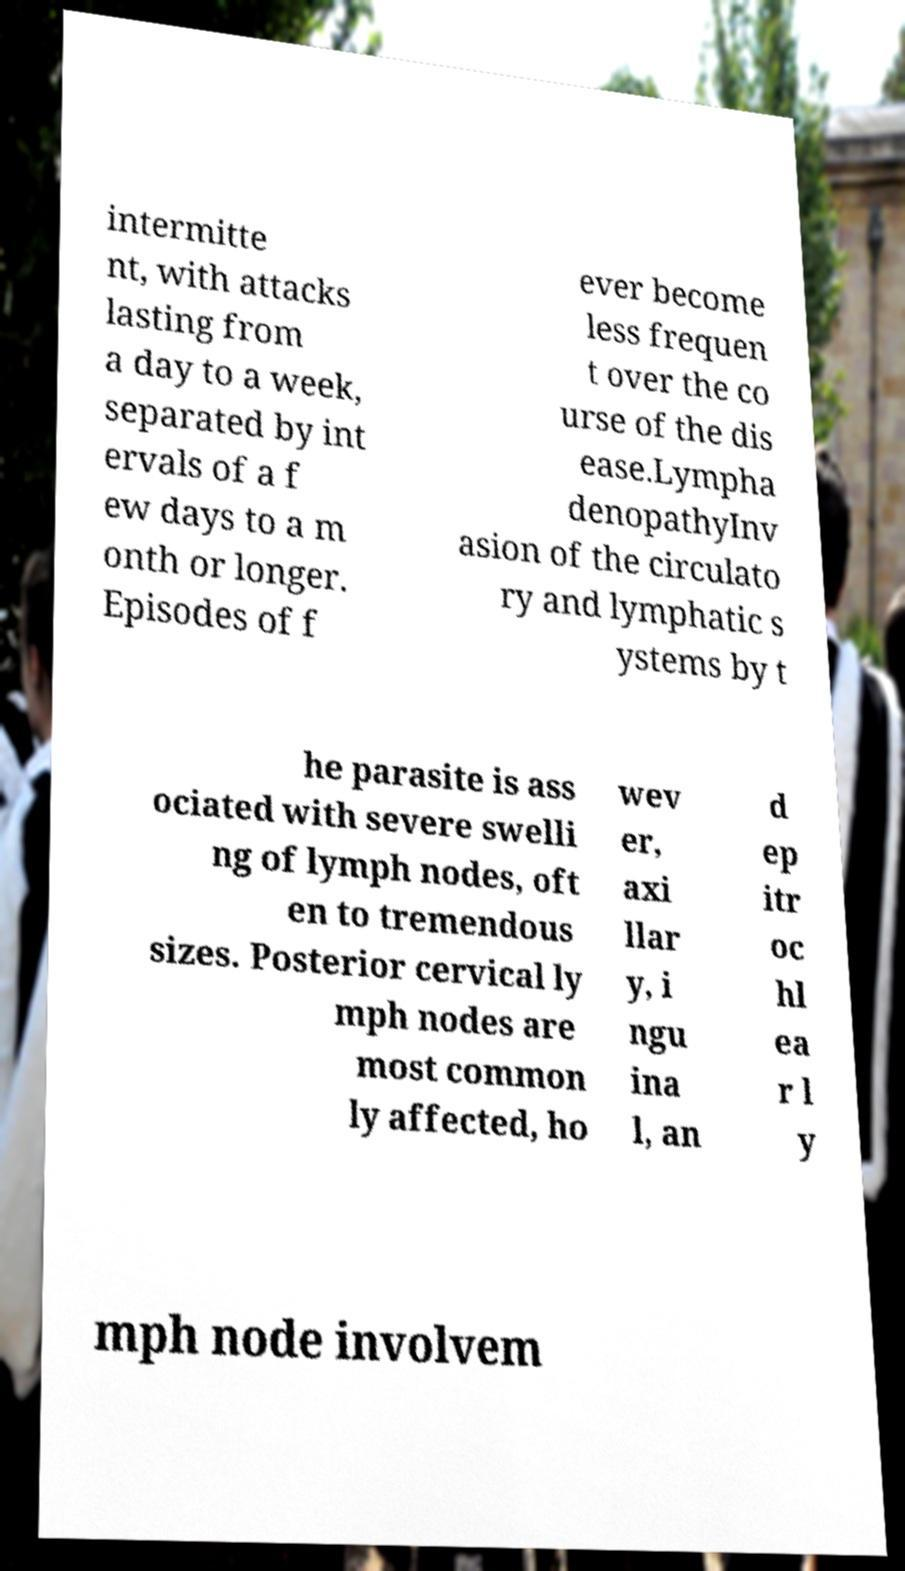For documentation purposes, I need the text within this image transcribed. Could you provide that? intermitte nt, with attacks lasting from a day to a week, separated by int ervals of a f ew days to a m onth or longer. Episodes of f ever become less frequen t over the co urse of the dis ease.Lympha denopathyInv asion of the circulato ry and lymphatic s ystems by t he parasite is ass ociated with severe swelli ng of lymph nodes, oft en to tremendous sizes. Posterior cervical ly mph nodes are most common ly affected, ho wev er, axi llar y, i ngu ina l, an d ep itr oc hl ea r l y mph node involvem 